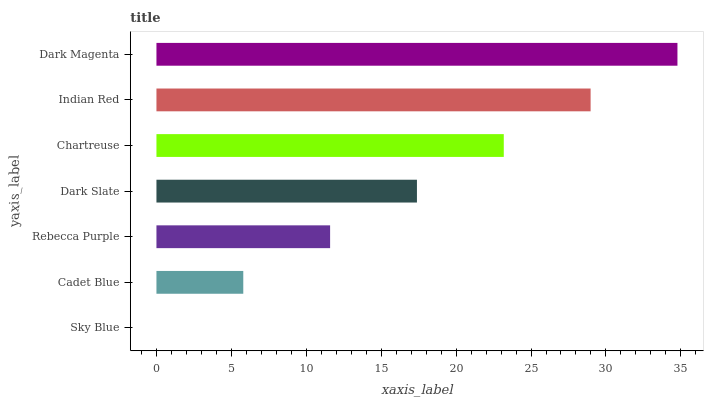Is Sky Blue the minimum?
Answer yes or no. Yes. Is Dark Magenta the maximum?
Answer yes or no. Yes. Is Cadet Blue the minimum?
Answer yes or no. No. Is Cadet Blue the maximum?
Answer yes or no. No. Is Cadet Blue greater than Sky Blue?
Answer yes or no. Yes. Is Sky Blue less than Cadet Blue?
Answer yes or no. Yes. Is Sky Blue greater than Cadet Blue?
Answer yes or no. No. Is Cadet Blue less than Sky Blue?
Answer yes or no. No. Is Dark Slate the high median?
Answer yes or no. Yes. Is Dark Slate the low median?
Answer yes or no. Yes. Is Chartreuse the high median?
Answer yes or no. No. Is Indian Red the low median?
Answer yes or no. No. 